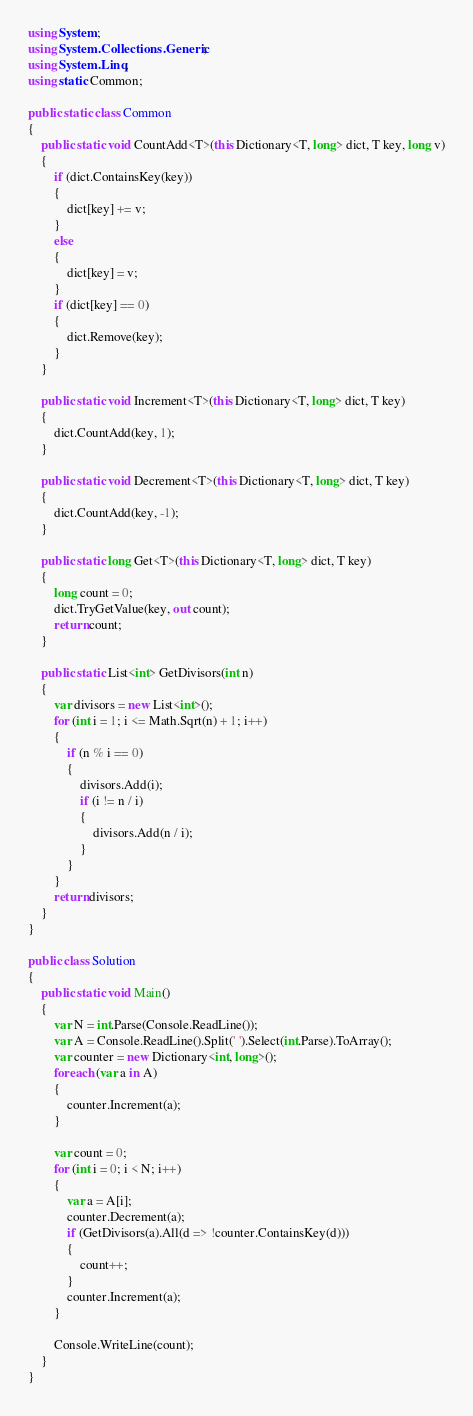<code> <loc_0><loc_0><loc_500><loc_500><_C#_>using System;
using System.Collections.Generic;
using System.Linq;
using static Common;

public static class Common
{
    public static void CountAdd<T>(this Dictionary<T, long> dict, T key, long v)
    {
        if (dict.ContainsKey(key))
        {
            dict[key] += v;
        }
        else
        {
            dict[key] = v;
        }
        if (dict[key] == 0)
        {
            dict.Remove(key);
        }
    }

    public static void Increment<T>(this Dictionary<T, long> dict, T key)
    {
        dict.CountAdd(key, 1);
    }

    public static void Decrement<T>(this Dictionary<T, long> dict, T key)
    {
        dict.CountAdd(key, -1);
    }

    public static long Get<T>(this Dictionary<T, long> dict, T key)
    {
        long count = 0;
        dict.TryGetValue(key, out count);
        return count;
    }

    public static List<int> GetDivisors(int n)
    {
        var divisors = new List<int>();
        for (int i = 1; i <= Math.Sqrt(n) + 1; i++)
        {
            if (n % i == 0)
            {
                divisors.Add(i);
                if (i != n / i)
                {
                    divisors.Add(n / i);
                }
            }
        }
        return divisors;
    }
}

public class Solution
{
    public static void Main()
    {
        var N = int.Parse(Console.ReadLine());
        var A = Console.ReadLine().Split(' ').Select(int.Parse).ToArray();
        var counter = new Dictionary<int, long>();
        foreach (var a in A)
        {
            counter.Increment(a);
        }

        var count = 0;
        for (int i = 0; i < N; i++)
        {
            var a = A[i];
            counter.Decrement(a);
            if (GetDivisors(a).All(d => !counter.ContainsKey(d)))
            {
                count++;
            }
            counter.Increment(a);
        }

        Console.WriteLine(count);
    }
}</code> 